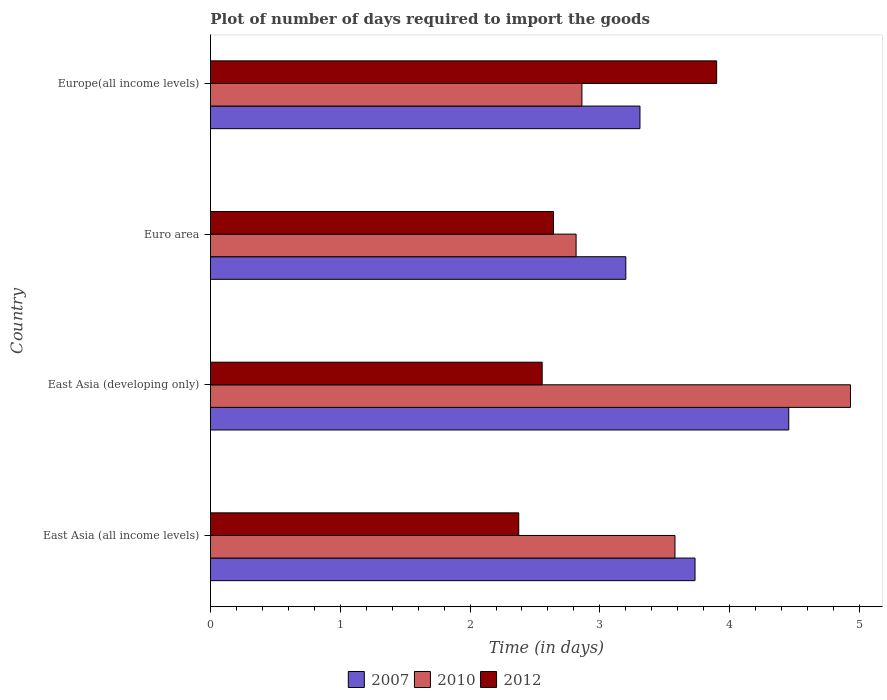How many different coloured bars are there?
Give a very brief answer. 3. How many bars are there on the 1st tick from the bottom?
Your answer should be very brief. 3. What is the label of the 2nd group of bars from the top?
Provide a short and direct response. Euro area. What is the time required to import goods in 2012 in East Asia (developing only)?
Your answer should be very brief. 2.56. Across all countries, what is the maximum time required to import goods in 2007?
Ensure brevity in your answer.  4.46. Across all countries, what is the minimum time required to import goods in 2010?
Make the answer very short. 2.82. In which country was the time required to import goods in 2010 maximum?
Keep it short and to the point. East Asia (developing only). In which country was the time required to import goods in 2010 minimum?
Your answer should be compact. Euro area. What is the total time required to import goods in 2010 in the graph?
Offer a terse response. 14.19. What is the difference between the time required to import goods in 2012 in East Asia (all income levels) and that in Europe(all income levels)?
Your response must be concise. -1.52. What is the difference between the time required to import goods in 2007 in Euro area and the time required to import goods in 2012 in East Asia (all income levels)?
Offer a terse response. 0.83. What is the average time required to import goods in 2007 per country?
Provide a succinct answer. 3.67. What is the difference between the time required to import goods in 2012 and time required to import goods in 2010 in Europe(all income levels)?
Provide a succinct answer. 1.04. What is the ratio of the time required to import goods in 2007 in East Asia (developing only) to that in Europe(all income levels)?
Provide a succinct answer. 1.35. Is the difference between the time required to import goods in 2012 in East Asia (all income levels) and Europe(all income levels) greater than the difference between the time required to import goods in 2010 in East Asia (all income levels) and Europe(all income levels)?
Make the answer very short. No. What is the difference between the highest and the second highest time required to import goods in 2012?
Provide a short and direct response. 1.26. What is the difference between the highest and the lowest time required to import goods in 2010?
Your answer should be compact. 2.11. Is the sum of the time required to import goods in 2010 in East Asia (all income levels) and Euro area greater than the maximum time required to import goods in 2012 across all countries?
Offer a very short reply. Yes. What does the 3rd bar from the top in Europe(all income levels) represents?
Your answer should be compact. 2007. What does the 1st bar from the bottom in East Asia (all income levels) represents?
Your response must be concise. 2007. Is it the case that in every country, the sum of the time required to import goods in 2012 and time required to import goods in 2007 is greater than the time required to import goods in 2010?
Make the answer very short. Yes. How many bars are there?
Your answer should be compact. 12. Are all the bars in the graph horizontal?
Your answer should be compact. Yes. What is the difference between two consecutive major ticks on the X-axis?
Ensure brevity in your answer.  1. How are the legend labels stacked?
Provide a short and direct response. Horizontal. What is the title of the graph?
Provide a succinct answer. Plot of number of days required to import the goods. Does "1975" appear as one of the legend labels in the graph?
Keep it short and to the point. No. What is the label or title of the X-axis?
Provide a short and direct response. Time (in days). What is the Time (in days) in 2007 in East Asia (all income levels)?
Your answer should be compact. 3.73. What is the Time (in days) of 2010 in East Asia (all income levels)?
Provide a succinct answer. 3.58. What is the Time (in days) of 2012 in East Asia (all income levels)?
Your answer should be compact. 2.38. What is the Time (in days) in 2007 in East Asia (developing only)?
Your response must be concise. 4.46. What is the Time (in days) of 2010 in East Asia (developing only)?
Offer a terse response. 4.93. What is the Time (in days) of 2012 in East Asia (developing only)?
Offer a very short reply. 2.56. What is the Time (in days) in 2007 in Euro area?
Offer a terse response. 3.2. What is the Time (in days) of 2010 in Euro area?
Ensure brevity in your answer.  2.82. What is the Time (in days) of 2012 in Euro area?
Keep it short and to the point. 2.64. What is the Time (in days) of 2007 in Europe(all income levels)?
Make the answer very short. 3.31. What is the Time (in days) in 2010 in Europe(all income levels)?
Keep it short and to the point. 2.86. Across all countries, what is the maximum Time (in days) in 2007?
Your answer should be compact. 4.46. Across all countries, what is the maximum Time (in days) of 2010?
Offer a very short reply. 4.93. Across all countries, what is the maximum Time (in days) in 2012?
Make the answer very short. 3.9. Across all countries, what is the minimum Time (in days) in 2007?
Make the answer very short. 3.2. Across all countries, what is the minimum Time (in days) in 2010?
Provide a succinct answer. 2.82. Across all countries, what is the minimum Time (in days) in 2012?
Provide a succinct answer. 2.38. What is the total Time (in days) of 2007 in the graph?
Give a very brief answer. 14.7. What is the total Time (in days) of 2010 in the graph?
Make the answer very short. 14.19. What is the total Time (in days) of 2012 in the graph?
Your response must be concise. 11.47. What is the difference between the Time (in days) of 2007 in East Asia (all income levels) and that in East Asia (developing only)?
Offer a very short reply. -0.72. What is the difference between the Time (in days) in 2010 in East Asia (all income levels) and that in East Asia (developing only)?
Keep it short and to the point. -1.35. What is the difference between the Time (in days) of 2012 in East Asia (all income levels) and that in East Asia (developing only)?
Provide a short and direct response. -0.18. What is the difference between the Time (in days) in 2007 in East Asia (all income levels) and that in Euro area?
Provide a short and direct response. 0.53. What is the difference between the Time (in days) of 2010 in East Asia (all income levels) and that in Euro area?
Keep it short and to the point. 0.76. What is the difference between the Time (in days) of 2012 in East Asia (all income levels) and that in Euro area?
Make the answer very short. -0.27. What is the difference between the Time (in days) of 2007 in East Asia (all income levels) and that in Europe(all income levels)?
Give a very brief answer. 0.42. What is the difference between the Time (in days) of 2010 in East Asia (all income levels) and that in Europe(all income levels)?
Your response must be concise. 0.72. What is the difference between the Time (in days) of 2012 in East Asia (all income levels) and that in Europe(all income levels)?
Provide a succinct answer. -1.52. What is the difference between the Time (in days) in 2007 in East Asia (developing only) and that in Euro area?
Provide a short and direct response. 1.26. What is the difference between the Time (in days) in 2010 in East Asia (developing only) and that in Euro area?
Give a very brief answer. 2.11. What is the difference between the Time (in days) of 2012 in East Asia (developing only) and that in Euro area?
Provide a short and direct response. -0.09. What is the difference between the Time (in days) in 2007 in East Asia (developing only) and that in Europe(all income levels)?
Ensure brevity in your answer.  1.15. What is the difference between the Time (in days) of 2010 in East Asia (developing only) and that in Europe(all income levels)?
Your answer should be very brief. 2.07. What is the difference between the Time (in days) in 2012 in East Asia (developing only) and that in Europe(all income levels)?
Your response must be concise. -1.34. What is the difference between the Time (in days) in 2007 in Euro area and that in Europe(all income levels)?
Your answer should be compact. -0.11. What is the difference between the Time (in days) of 2010 in Euro area and that in Europe(all income levels)?
Provide a short and direct response. -0.04. What is the difference between the Time (in days) of 2012 in Euro area and that in Europe(all income levels)?
Provide a succinct answer. -1.26. What is the difference between the Time (in days) in 2007 in East Asia (all income levels) and the Time (in days) in 2010 in East Asia (developing only)?
Your answer should be very brief. -1.2. What is the difference between the Time (in days) in 2007 in East Asia (all income levels) and the Time (in days) in 2012 in East Asia (developing only)?
Keep it short and to the point. 1.18. What is the difference between the Time (in days) in 2010 in East Asia (all income levels) and the Time (in days) in 2012 in East Asia (developing only)?
Your answer should be compact. 1.02. What is the difference between the Time (in days) of 2007 in East Asia (all income levels) and the Time (in days) of 2010 in Euro area?
Provide a succinct answer. 0.92. What is the difference between the Time (in days) in 2007 in East Asia (all income levels) and the Time (in days) in 2012 in Euro area?
Provide a short and direct response. 1.09. What is the difference between the Time (in days) in 2010 in East Asia (all income levels) and the Time (in days) in 2012 in Euro area?
Offer a terse response. 0.94. What is the difference between the Time (in days) in 2007 in East Asia (all income levels) and the Time (in days) in 2010 in Europe(all income levels)?
Provide a short and direct response. 0.87. What is the difference between the Time (in days) of 2007 in East Asia (all income levels) and the Time (in days) of 2012 in Europe(all income levels)?
Your answer should be very brief. -0.17. What is the difference between the Time (in days) in 2010 in East Asia (all income levels) and the Time (in days) in 2012 in Europe(all income levels)?
Make the answer very short. -0.32. What is the difference between the Time (in days) of 2007 in East Asia (developing only) and the Time (in days) of 2010 in Euro area?
Give a very brief answer. 1.64. What is the difference between the Time (in days) in 2007 in East Asia (developing only) and the Time (in days) in 2012 in Euro area?
Keep it short and to the point. 1.81. What is the difference between the Time (in days) in 2010 in East Asia (developing only) and the Time (in days) in 2012 in Euro area?
Give a very brief answer. 2.29. What is the difference between the Time (in days) of 2007 in East Asia (developing only) and the Time (in days) of 2010 in Europe(all income levels)?
Provide a succinct answer. 1.59. What is the difference between the Time (in days) in 2007 in East Asia (developing only) and the Time (in days) in 2012 in Europe(all income levels)?
Provide a succinct answer. 0.56. What is the difference between the Time (in days) of 2010 in East Asia (developing only) and the Time (in days) of 2012 in Europe(all income levels)?
Keep it short and to the point. 1.03. What is the difference between the Time (in days) in 2007 in Euro area and the Time (in days) in 2010 in Europe(all income levels)?
Ensure brevity in your answer.  0.34. What is the difference between the Time (in days) of 2007 in Euro area and the Time (in days) of 2012 in Europe(all income levels)?
Offer a very short reply. -0.7. What is the difference between the Time (in days) in 2010 in Euro area and the Time (in days) in 2012 in Europe(all income levels)?
Provide a succinct answer. -1.08. What is the average Time (in days) of 2007 per country?
Your answer should be very brief. 3.67. What is the average Time (in days) in 2010 per country?
Give a very brief answer. 3.55. What is the average Time (in days) in 2012 per country?
Your response must be concise. 2.87. What is the difference between the Time (in days) of 2007 and Time (in days) of 2010 in East Asia (all income levels)?
Provide a short and direct response. 0.15. What is the difference between the Time (in days) of 2007 and Time (in days) of 2012 in East Asia (all income levels)?
Offer a very short reply. 1.36. What is the difference between the Time (in days) of 2010 and Time (in days) of 2012 in East Asia (all income levels)?
Provide a short and direct response. 1.2. What is the difference between the Time (in days) of 2007 and Time (in days) of 2010 in East Asia (developing only)?
Keep it short and to the point. -0.48. What is the difference between the Time (in days) in 2010 and Time (in days) in 2012 in East Asia (developing only)?
Your answer should be very brief. 2.38. What is the difference between the Time (in days) in 2007 and Time (in days) in 2010 in Euro area?
Your answer should be very brief. 0.38. What is the difference between the Time (in days) of 2007 and Time (in days) of 2012 in Euro area?
Ensure brevity in your answer.  0.56. What is the difference between the Time (in days) of 2010 and Time (in days) of 2012 in Euro area?
Offer a very short reply. 0.17. What is the difference between the Time (in days) of 2007 and Time (in days) of 2010 in Europe(all income levels)?
Ensure brevity in your answer.  0.45. What is the difference between the Time (in days) of 2007 and Time (in days) of 2012 in Europe(all income levels)?
Your answer should be very brief. -0.59. What is the difference between the Time (in days) in 2010 and Time (in days) in 2012 in Europe(all income levels)?
Ensure brevity in your answer.  -1.04. What is the ratio of the Time (in days) of 2007 in East Asia (all income levels) to that in East Asia (developing only)?
Provide a succinct answer. 0.84. What is the ratio of the Time (in days) of 2010 in East Asia (all income levels) to that in East Asia (developing only)?
Keep it short and to the point. 0.73. What is the ratio of the Time (in days) of 2012 in East Asia (all income levels) to that in East Asia (developing only)?
Give a very brief answer. 0.93. What is the ratio of the Time (in days) of 2007 in East Asia (all income levels) to that in Euro area?
Your response must be concise. 1.17. What is the ratio of the Time (in days) of 2010 in East Asia (all income levels) to that in Euro area?
Your response must be concise. 1.27. What is the ratio of the Time (in days) in 2012 in East Asia (all income levels) to that in Euro area?
Your response must be concise. 0.9. What is the ratio of the Time (in days) of 2007 in East Asia (all income levels) to that in Europe(all income levels)?
Your response must be concise. 1.13. What is the ratio of the Time (in days) of 2010 in East Asia (all income levels) to that in Europe(all income levels)?
Give a very brief answer. 1.25. What is the ratio of the Time (in days) of 2012 in East Asia (all income levels) to that in Europe(all income levels)?
Your answer should be very brief. 0.61. What is the ratio of the Time (in days) in 2007 in East Asia (developing only) to that in Euro area?
Give a very brief answer. 1.39. What is the ratio of the Time (in days) in 2010 in East Asia (developing only) to that in Euro area?
Ensure brevity in your answer.  1.75. What is the ratio of the Time (in days) of 2007 in East Asia (developing only) to that in Europe(all income levels)?
Make the answer very short. 1.35. What is the ratio of the Time (in days) in 2010 in East Asia (developing only) to that in Europe(all income levels)?
Give a very brief answer. 1.72. What is the ratio of the Time (in days) of 2012 in East Asia (developing only) to that in Europe(all income levels)?
Offer a very short reply. 0.66. What is the ratio of the Time (in days) of 2007 in Euro area to that in Europe(all income levels)?
Your answer should be very brief. 0.97. What is the ratio of the Time (in days) in 2010 in Euro area to that in Europe(all income levels)?
Provide a short and direct response. 0.98. What is the ratio of the Time (in days) of 2012 in Euro area to that in Europe(all income levels)?
Keep it short and to the point. 0.68. What is the difference between the highest and the second highest Time (in days) of 2007?
Offer a terse response. 0.72. What is the difference between the highest and the second highest Time (in days) in 2010?
Make the answer very short. 1.35. What is the difference between the highest and the second highest Time (in days) in 2012?
Keep it short and to the point. 1.26. What is the difference between the highest and the lowest Time (in days) of 2007?
Your answer should be compact. 1.26. What is the difference between the highest and the lowest Time (in days) in 2010?
Provide a succinct answer. 2.11. What is the difference between the highest and the lowest Time (in days) of 2012?
Your response must be concise. 1.52. 